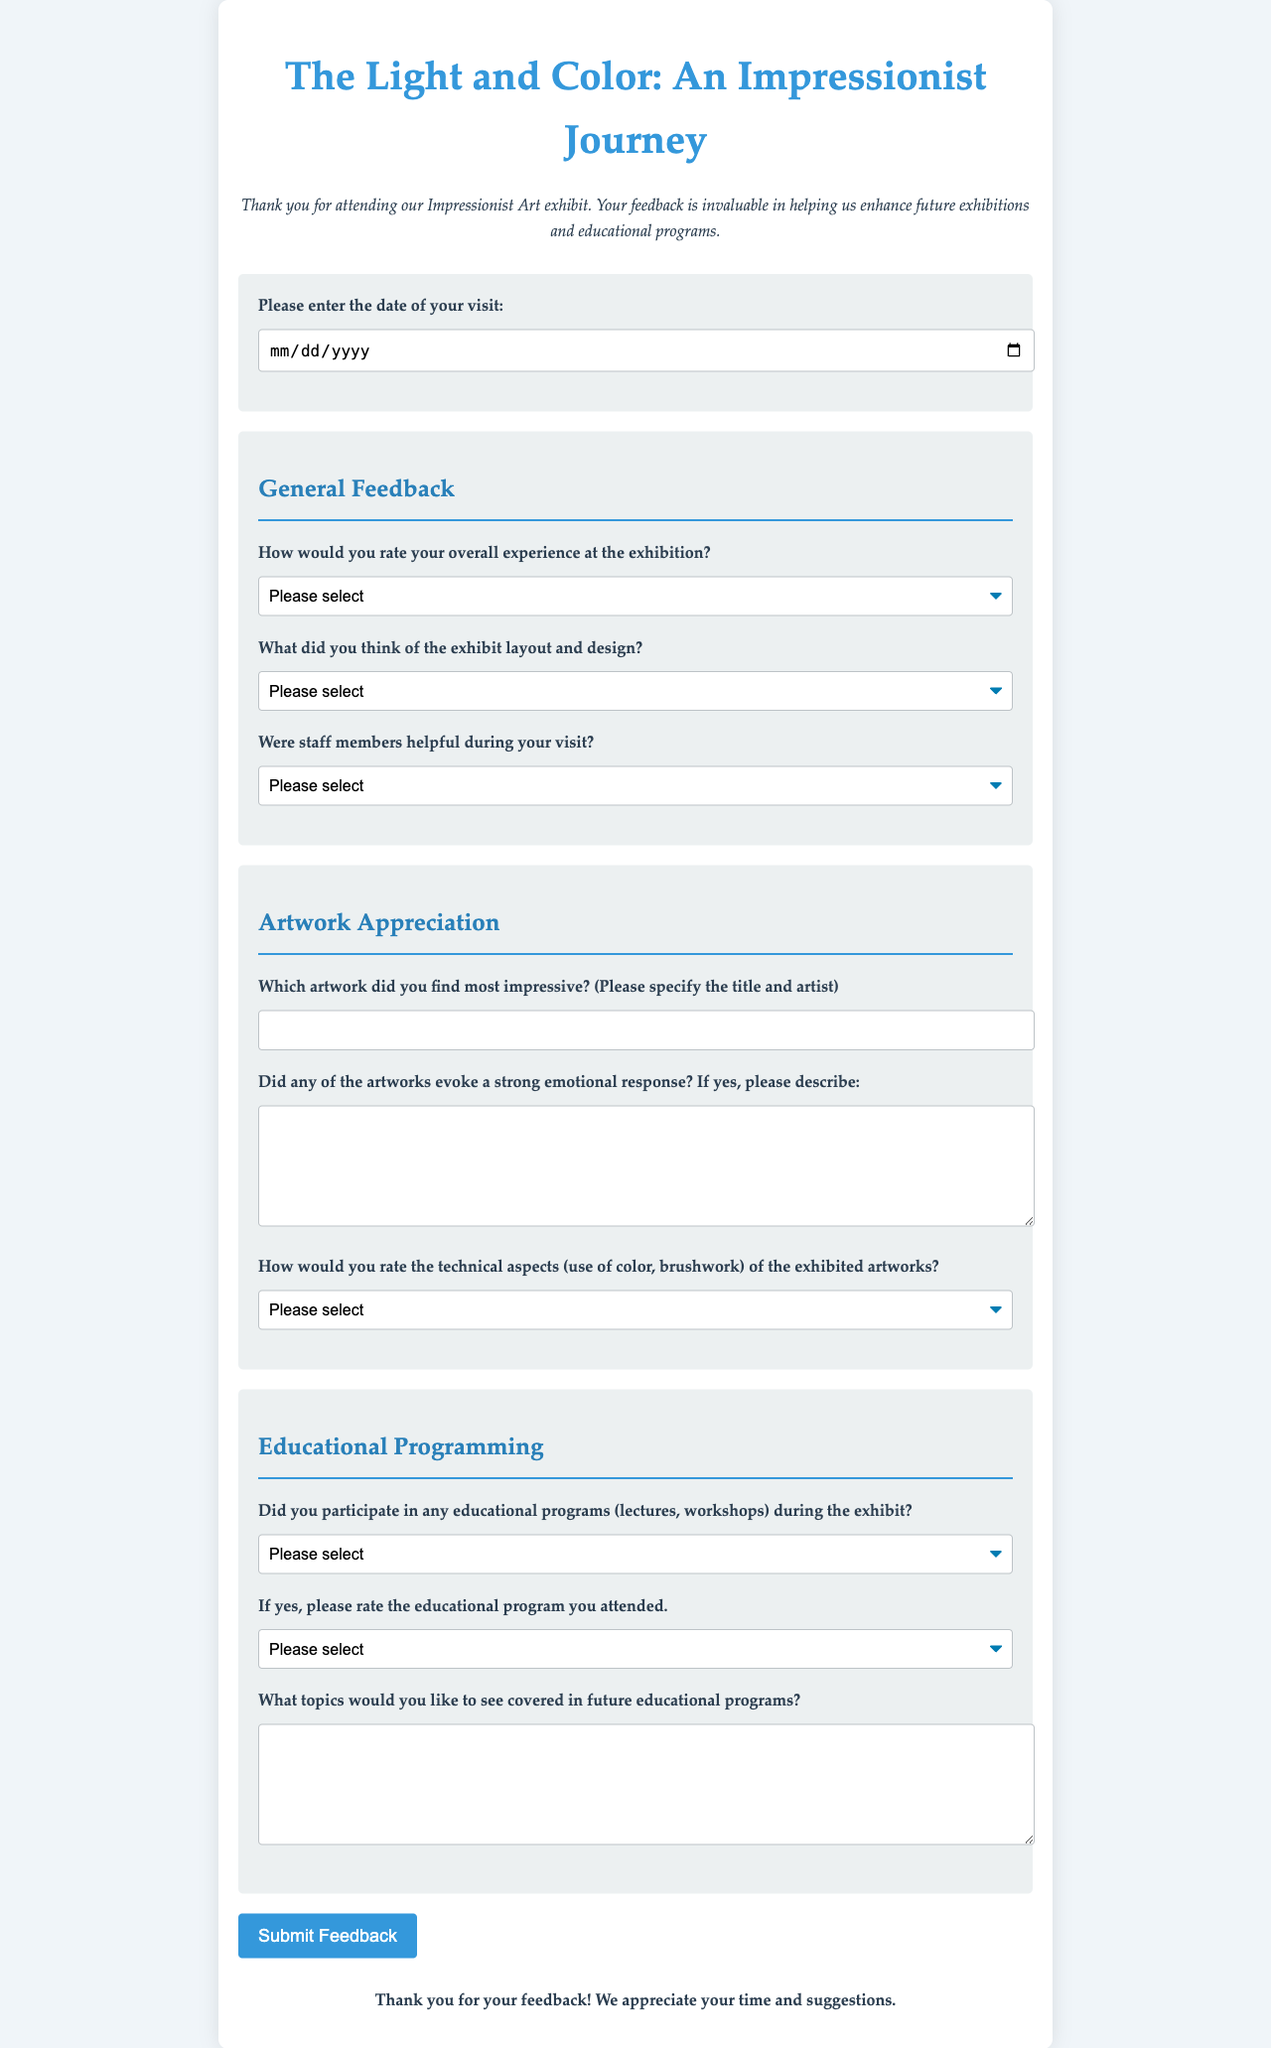what is the title of the exhibit? The title of the exhibit can be found at the top of the document.
Answer: The Light and Color: An Impressionist Journey what is the required feedback about the date of visit? The document specifies that visitors must enter the date of their visit.
Answer: Date of visit how many sections are in the feedback form? The feedback form contains four distinct sections: General Feedback, Artwork Appreciation, Educational Programming, and Conclusion.
Answer: Four what is the first question under Educational Programming? The first question in the Educational Programming section asks about participation in educational programs during the exhibit.
Answer: Did you participate in any educational programs (lectures, workshops) during the exhibit? how many rating options are provided for overall experience? The document lists four options for rating the overall experience at the exhibition.
Answer: Four what phrase is used for visitors to describe their favorite artwork? The document prompts visitors to specify the title and artist of their favorite artwork.
Answer: Please specify the title and artist what is the color of the conclusion text? The conclusion text indicates that it is bolded and centered, following the colors used throughout.
Answer: Bold how does the submit button change on hover? The button is styled to change its background color when hovered over.
Answer: Darker blue what options are listed for rating the technical aspects of the artworks? The document provides four rating options for the technical aspects of the exhibited artworks.
Answer: Excellent, Good, Fair, Poor 